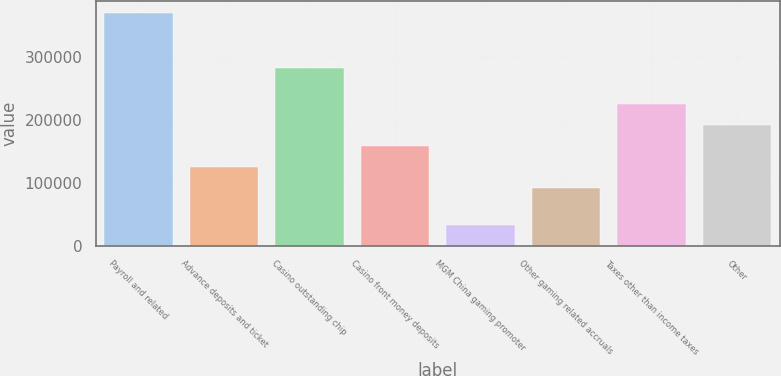Convert chart to OTSL. <chart><loc_0><loc_0><loc_500><loc_500><bar_chart><fcel>Payroll and related<fcel>Advance deposits and ticket<fcel>Casino outstanding chip<fcel>Casino front money deposits<fcel>MGM China gaming promoter<fcel>Other gaming related accruals<fcel>Taxes other than income taxes<fcel>Other<nl><fcel>370672<fcel>125079<fcel>282810<fcel>158840<fcel>33064<fcel>91318<fcel>226361<fcel>192600<nl></chart> 